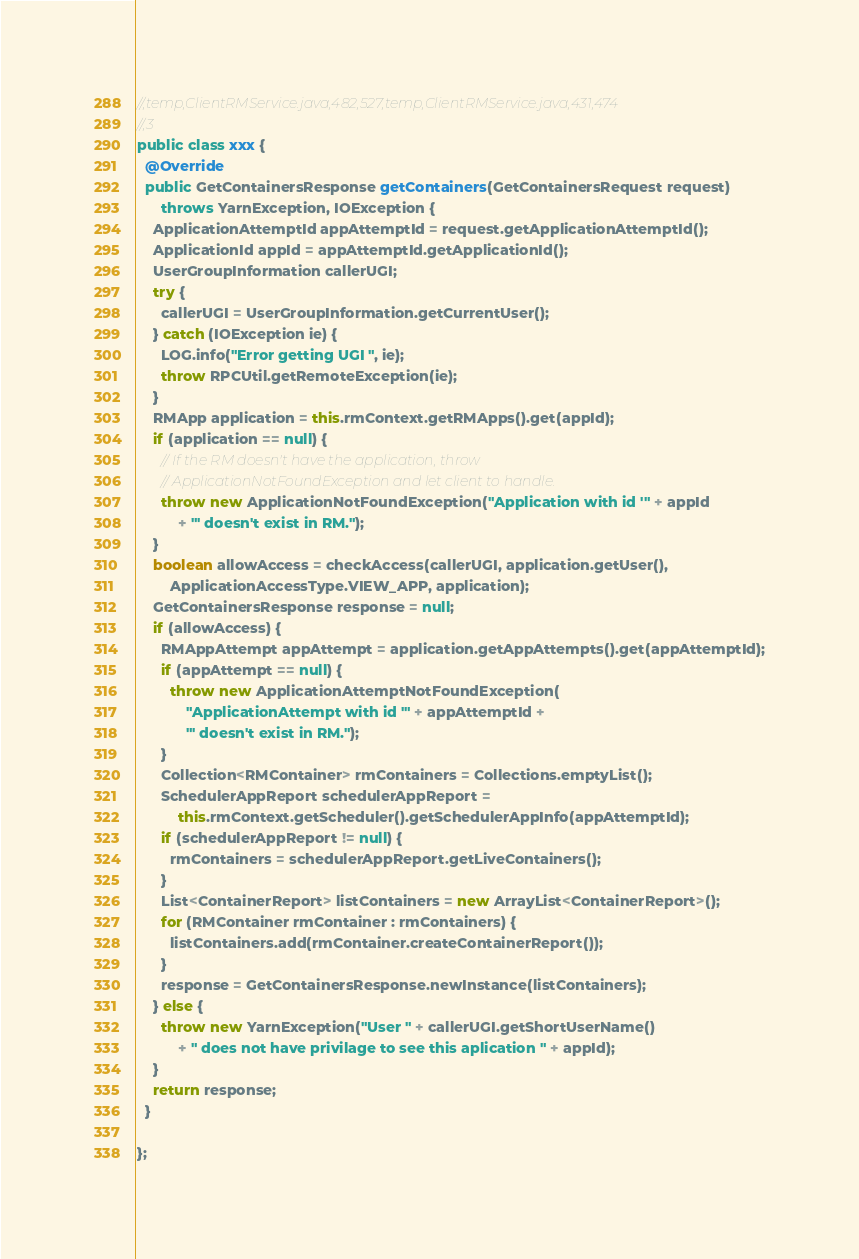<code> <loc_0><loc_0><loc_500><loc_500><_Java_>//,temp,ClientRMService.java,482,527,temp,ClientRMService.java,431,474
//,3
public class xxx {
  @Override
  public GetContainersResponse getContainers(GetContainersRequest request)
      throws YarnException, IOException {
    ApplicationAttemptId appAttemptId = request.getApplicationAttemptId();
    ApplicationId appId = appAttemptId.getApplicationId();
    UserGroupInformation callerUGI;
    try {
      callerUGI = UserGroupInformation.getCurrentUser();
    } catch (IOException ie) {
      LOG.info("Error getting UGI ", ie);
      throw RPCUtil.getRemoteException(ie);
    }
    RMApp application = this.rmContext.getRMApps().get(appId);
    if (application == null) {
      // If the RM doesn't have the application, throw
      // ApplicationNotFoundException and let client to handle.
      throw new ApplicationNotFoundException("Application with id '" + appId
          + "' doesn't exist in RM.");
    }
    boolean allowAccess = checkAccess(callerUGI, application.getUser(),
        ApplicationAccessType.VIEW_APP, application);
    GetContainersResponse response = null;
    if (allowAccess) {
      RMAppAttempt appAttempt = application.getAppAttempts().get(appAttemptId);
      if (appAttempt == null) {
        throw new ApplicationAttemptNotFoundException(
            "ApplicationAttempt with id '" + appAttemptId +
            "' doesn't exist in RM.");
      }
      Collection<RMContainer> rmContainers = Collections.emptyList();
      SchedulerAppReport schedulerAppReport =
          this.rmContext.getScheduler().getSchedulerAppInfo(appAttemptId);
      if (schedulerAppReport != null) {
        rmContainers = schedulerAppReport.getLiveContainers();
      }
      List<ContainerReport> listContainers = new ArrayList<ContainerReport>();
      for (RMContainer rmContainer : rmContainers) {
        listContainers.add(rmContainer.createContainerReport());
      }
      response = GetContainersResponse.newInstance(listContainers);
    } else {
      throw new YarnException("User " + callerUGI.getShortUserName()
          + " does not have privilage to see this aplication " + appId);
    }
    return response;
  }

};</code> 